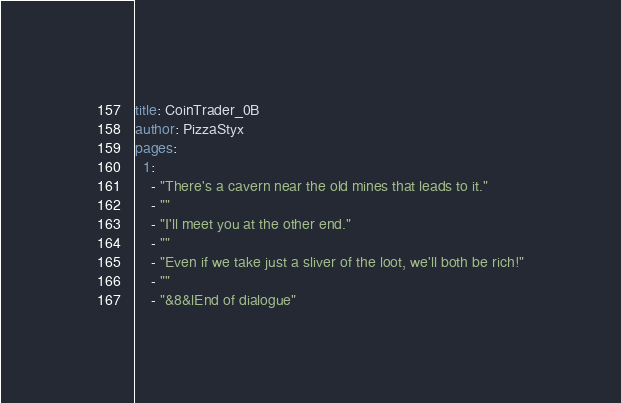<code> <loc_0><loc_0><loc_500><loc_500><_YAML_>title: CoinTrader_0B
author: PizzaStyx
pages:
  1:
    - "There's a cavern near the old mines that leads to it."
    - ""
    - "I'll meet you at the other end."
    - ""
    - "Even if we take just a sliver of the loot, we'll both be rich!"
    - ""
    - "&8&lEnd of dialogue"</code> 